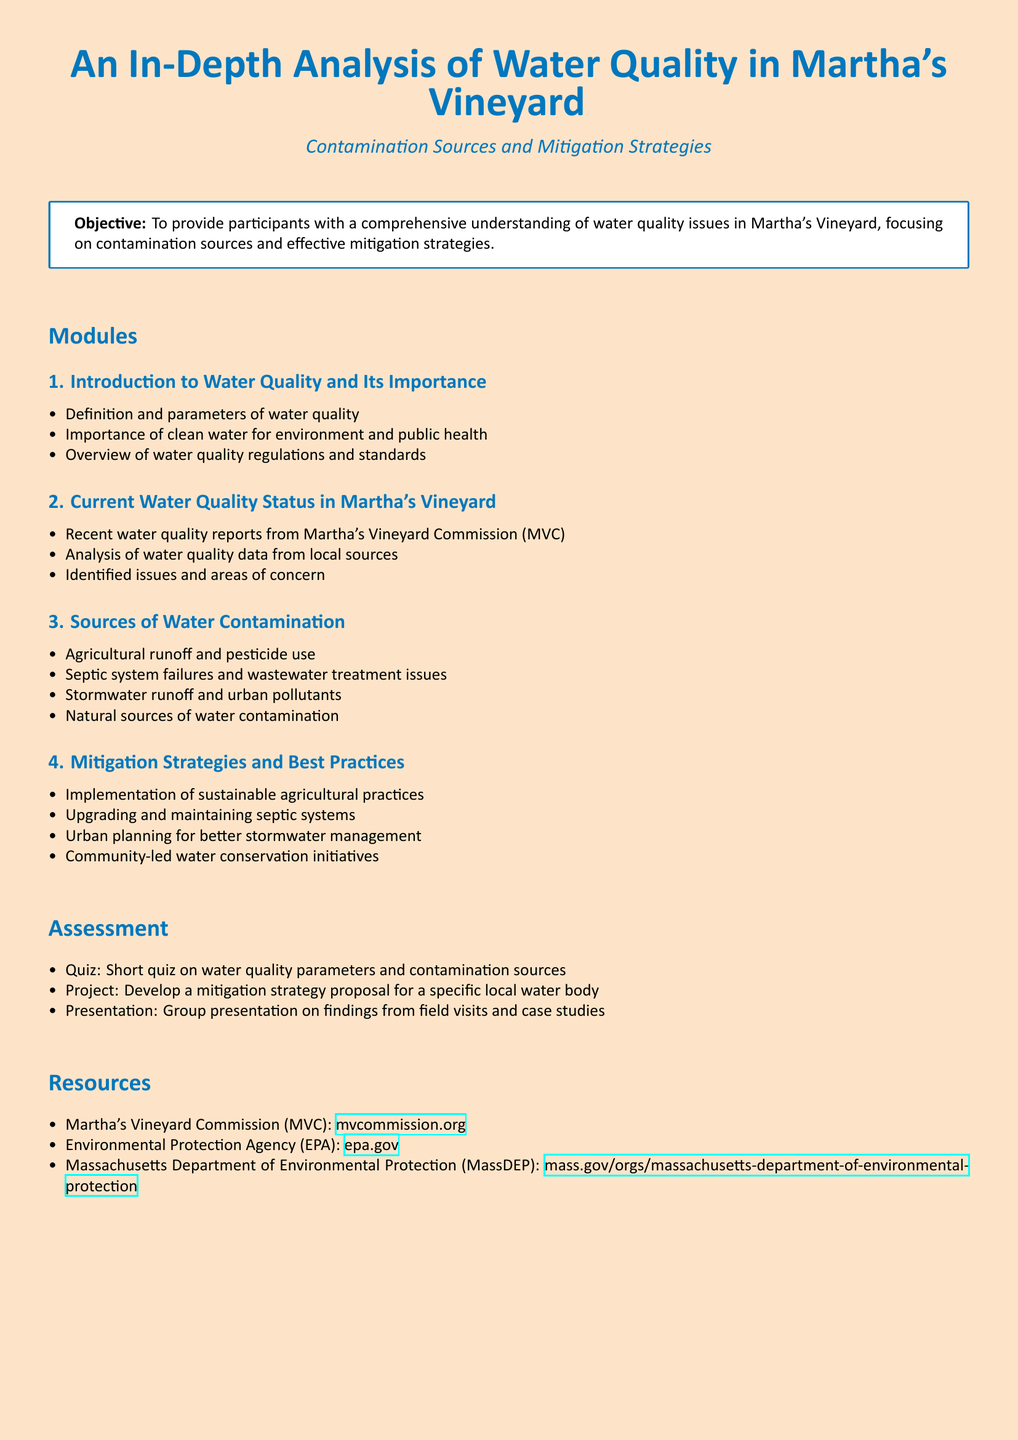what is the main objective of the syllabus? The objective outlined in the syllabus is to provide participants with a comprehensive understanding of water quality issues in Martha's Vineyard, focusing on contamination sources and effective mitigation strategies.
Answer: comprehensive understanding what is the first module in the syllabus? The first module is the introduction section that covers the importance of water quality, its definition, and related regulations.
Answer: Introduction to Water Quality and Its Importance what issue does agricultural runoff contribute to? Agricultural runoff contributes to water contamination as outlined in the section on Sources of Water Contamination.
Answer: water contamination how many modules are there in the syllabus? The syllabus lists four primary modules that address various aspects of water quality and contamination.
Answer: four which organization is mentioned as a resource for water quality information? The Martha's Vineyard Commission is mentioned as a resource in the syllabus for water quality data.
Answer: Martha's Vineyard Commission what is one mitigation strategy discussed in the syllabus? The syllabus suggests upgrading and maintaining septic systems as a mitigation strategy.
Answer: upgrading and maintaining septic systems what is assessed through a quiz according to the syllabus? The quiz assesses knowledge on water quality parameters and sources of contamination.
Answer: water quality parameters and contamination sources how many assessments are listed in the syllabus? The syllabus mentions three types of assessments for participants.
Answer: three what is the color theme used for the document? The document employs an ocean blue color theme for titles and headings against a sandy beach background.
Answer: ocean blue 